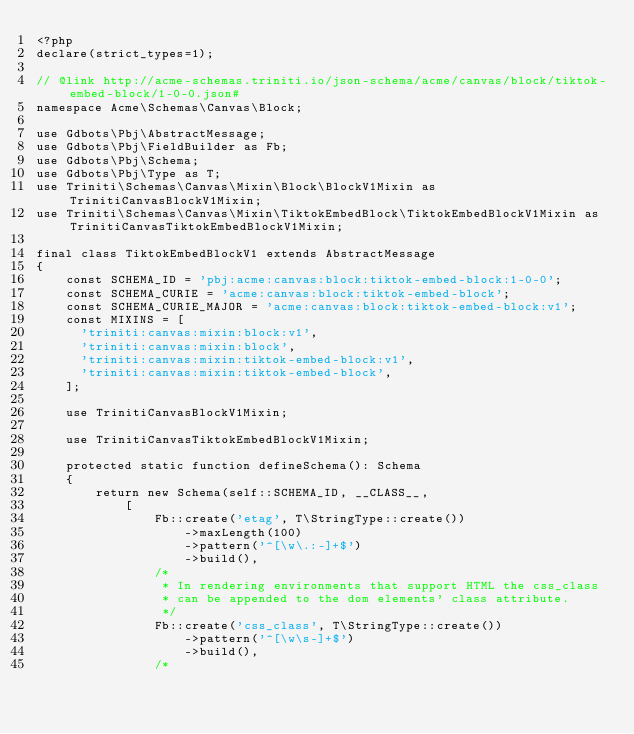Convert code to text. <code><loc_0><loc_0><loc_500><loc_500><_PHP_><?php
declare(strict_types=1);

// @link http://acme-schemas.triniti.io/json-schema/acme/canvas/block/tiktok-embed-block/1-0-0.json#
namespace Acme\Schemas\Canvas\Block;

use Gdbots\Pbj\AbstractMessage;
use Gdbots\Pbj\FieldBuilder as Fb;
use Gdbots\Pbj\Schema;
use Gdbots\Pbj\Type as T;
use Triniti\Schemas\Canvas\Mixin\Block\BlockV1Mixin as TrinitiCanvasBlockV1Mixin;
use Triniti\Schemas\Canvas\Mixin\TiktokEmbedBlock\TiktokEmbedBlockV1Mixin as TrinitiCanvasTiktokEmbedBlockV1Mixin;

final class TiktokEmbedBlockV1 extends AbstractMessage
{
    const SCHEMA_ID = 'pbj:acme:canvas:block:tiktok-embed-block:1-0-0';
    const SCHEMA_CURIE = 'acme:canvas:block:tiktok-embed-block';
    const SCHEMA_CURIE_MAJOR = 'acme:canvas:block:tiktok-embed-block:v1';
    const MIXINS = [
      'triniti:canvas:mixin:block:v1',
      'triniti:canvas:mixin:block',
      'triniti:canvas:mixin:tiktok-embed-block:v1',
      'triniti:canvas:mixin:tiktok-embed-block',
    ];

    use TrinitiCanvasBlockV1Mixin;

    use TrinitiCanvasTiktokEmbedBlockV1Mixin;

    protected static function defineSchema(): Schema
    {
        return new Schema(self::SCHEMA_ID, __CLASS__,
            [
                Fb::create('etag', T\StringType::create())
                    ->maxLength(100)
                    ->pattern('^[\w\.:-]+$')
                    ->build(),
                /*
                 * In rendering environments that support HTML the css_class
                 * can be appended to the dom elements' class attribute.
                 */
                Fb::create('css_class', T\StringType::create())
                    ->pattern('^[\w\s-]+$')
                    ->build(),
                /*</code> 